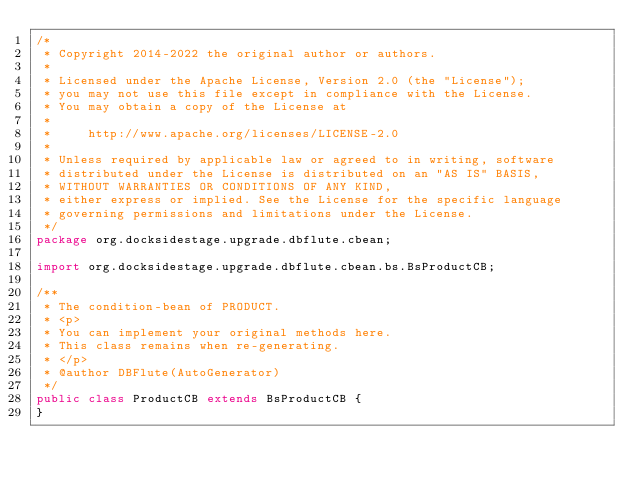<code> <loc_0><loc_0><loc_500><loc_500><_Java_>/*
 * Copyright 2014-2022 the original author or authors.
 *
 * Licensed under the Apache License, Version 2.0 (the "License");
 * you may not use this file except in compliance with the License.
 * You may obtain a copy of the License at
 *
 *     http://www.apache.org/licenses/LICENSE-2.0
 *
 * Unless required by applicable law or agreed to in writing, software
 * distributed under the License is distributed on an "AS IS" BASIS,
 * WITHOUT WARRANTIES OR CONDITIONS OF ANY KIND,
 * either express or implied. See the License for the specific language
 * governing permissions and limitations under the License.
 */
package org.docksidestage.upgrade.dbflute.cbean;

import org.docksidestage.upgrade.dbflute.cbean.bs.BsProductCB;

/**
 * The condition-bean of PRODUCT.
 * <p>
 * You can implement your original methods here.
 * This class remains when re-generating.
 * </p>
 * @author DBFlute(AutoGenerator)
 */
public class ProductCB extends BsProductCB {
}
</code> 